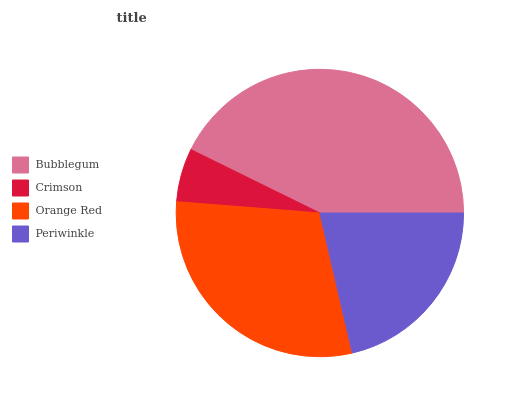Is Crimson the minimum?
Answer yes or no. Yes. Is Bubblegum the maximum?
Answer yes or no. Yes. Is Orange Red the minimum?
Answer yes or no. No. Is Orange Red the maximum?
Answer yes or no. No. Is Orange Red greater than Crimson?
Answer yes or no. Yes. Is Crimson less than Orange Red?
Answer yes or no. Yes. Is Crimson greater than Orange Red?
Answer yes or no. No. Is Orange Red less than Crimson?
Answer yes or no. No. Is Orange Red the high median?
Answer yes or no. Yes. Is Periwinkle the low median?
Answer yes or no. Yes. Is Periwinkle the high median?
Answer yes or no. No. Is Bubblegum the low median?
Answer yes or no. No. 